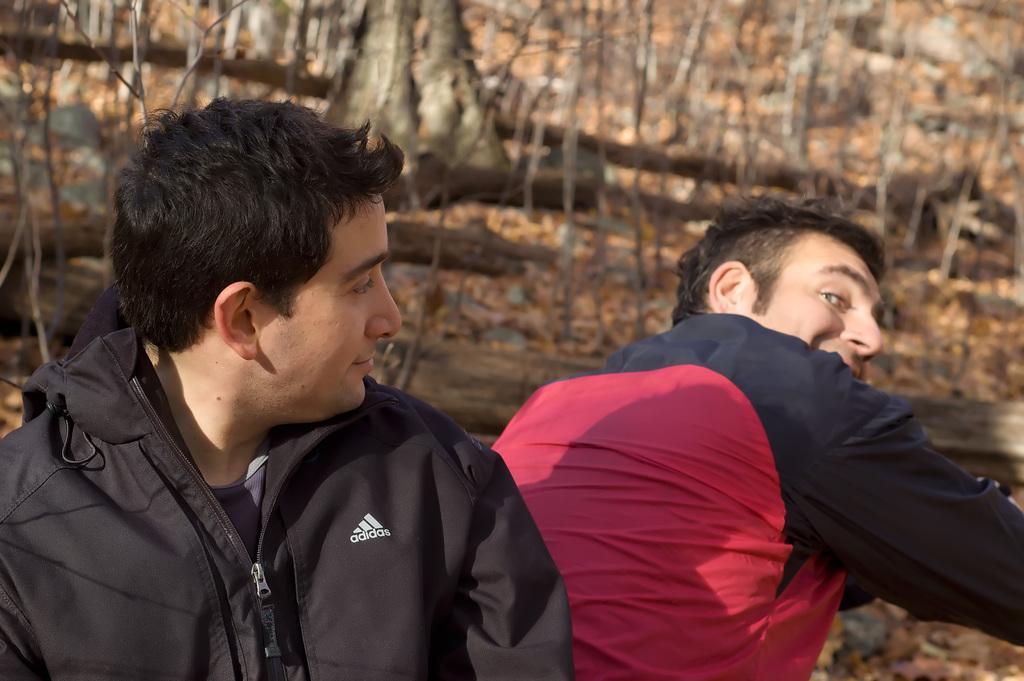Could you give a brief overview of what you see in this image? In this image there are persons sitting and smiling in the front and there are trees in the background and there are dry leaves on the ground. 